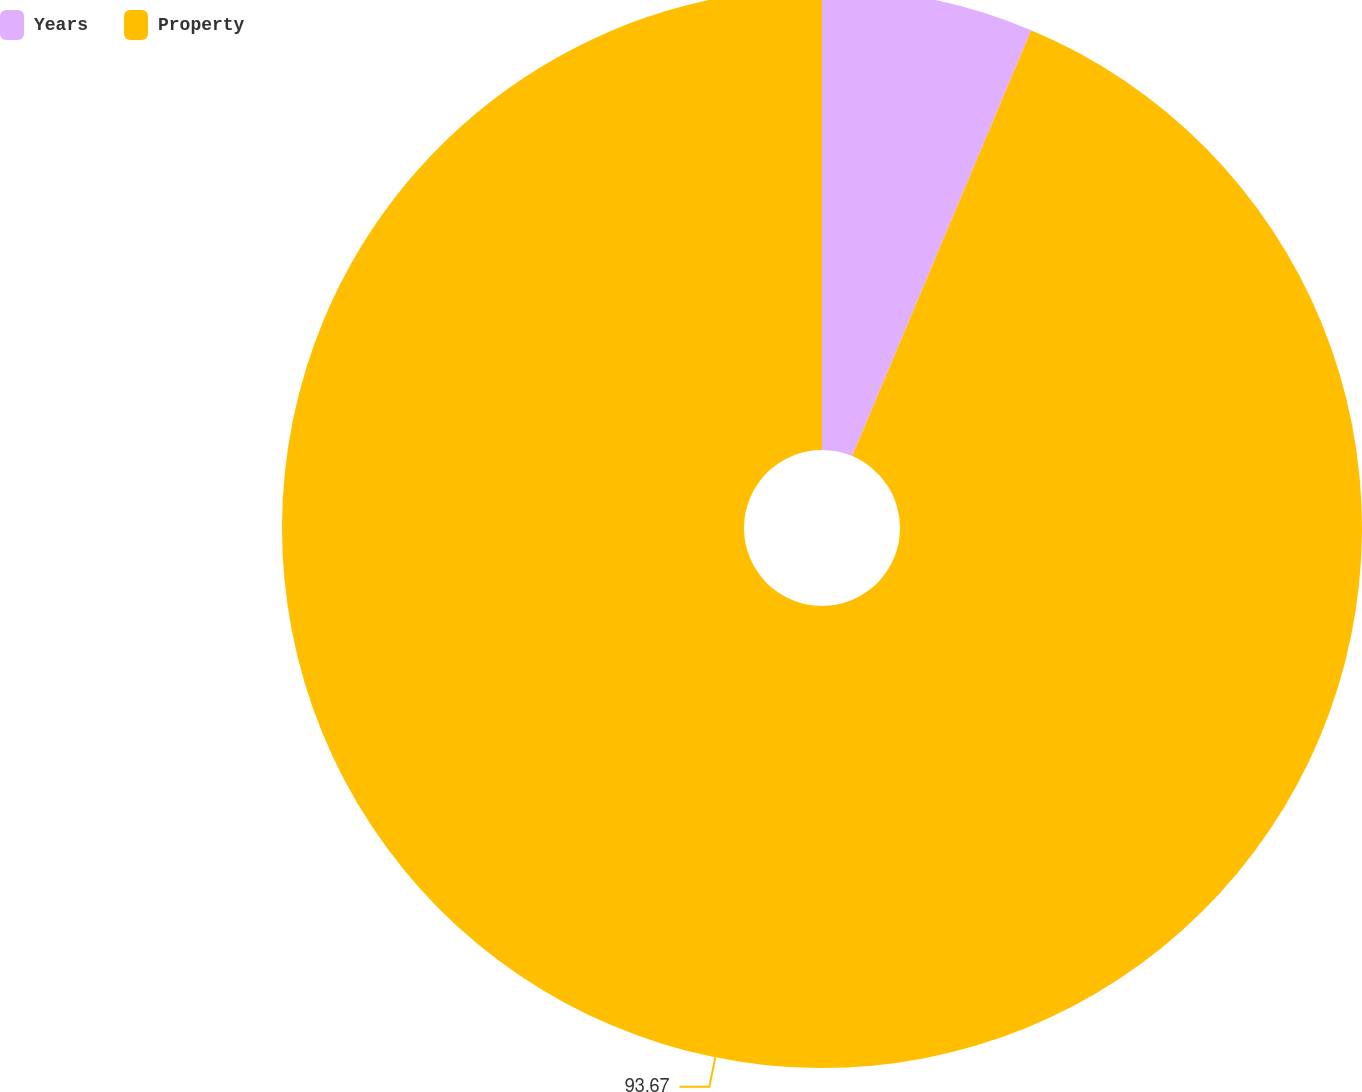<chart> <loc_0><loc_0><loc_500><loc_500><pie_chart><fcel>Years<fcel>Property<nl><fcel>6.33%<fcel>93.67%<nl></chart> 